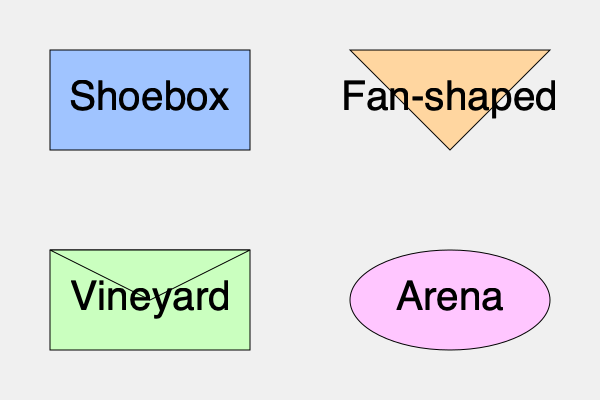Which concert hall layout is known for providing the best balance between direct and reverberant sound, often preferred for classical music performances? To answer this question, let's consider the acoustic properties of each concert hall layout:

1. Shoebox Hall:
   - Rectangular shape with parallel walls
   - Provides excellent lateral reflections
   - Balanced mix of direct and reverberant sound
   - Examples: Vienna's Musikverein, Boston Symphony Hall

2. Fan-shaped Hall:
   - Wider at the back, narrower at the stage
   - Good sight lines but less lateral reflection
   - Can result in weaker sound at the back
   - Examples: Royal Festival Hall in London

3. Vineyard Hall:
   - Terraced seating surrounding the stage
   - Good intimacy and visual connection
   - Can have uneven sound distribution
   - Examples: Berlin Philharmonie

4. Arena Hall:
   - Circular or oval shape
   - Central stage with seating all around
   - Can have issues with echo and sound focus
   - Examples: Royal Albert Hall in London

Among these layouts, the Shoebox Hall is widely regarded as the best for classical music performances. Its rectangular shape creates a balance between direct sound from the stage and reverberant sound from reflections off the parallel walls. This balance enhances the richness and clarity of the music, allowing for a full, immersive sound experience that is particularly suited to classical music.

The parallel walls in a Shoebox Hall promote lateral reflections, which contribute to the sense of spaciousness and envelopment in the sound. This is crucial for experiencing the full depth and nuance of a classical orchestra.

Many of the world's most acoustically renowned concert halls, such as Vienna's Musikverein and Boston Symphony Hall, use the Shoebox design. These halls are often cited as having near-perfect acoustics for classical music, further supporting the superiority of this layout for the genre.
Answer: Shoebox Hall 